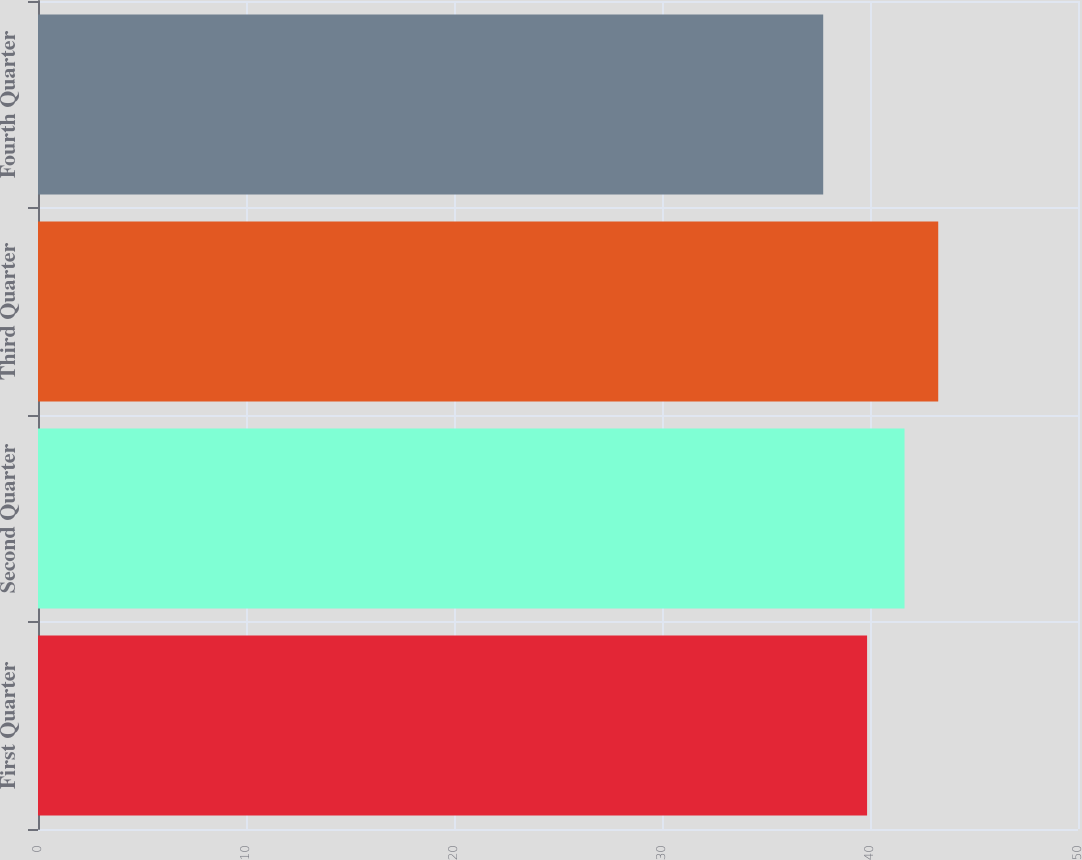<chart> <loc_0><loc_0><loc_500><loc_500><bar_chart><fcel>First Quarter<fcel>Second Quarter<fcel>Third Quarter<fcel>Fourth Quarter<nl><fcel>39.86<fcel>41.66<fcel>43.28<fcel>37.75<nl></chart> 